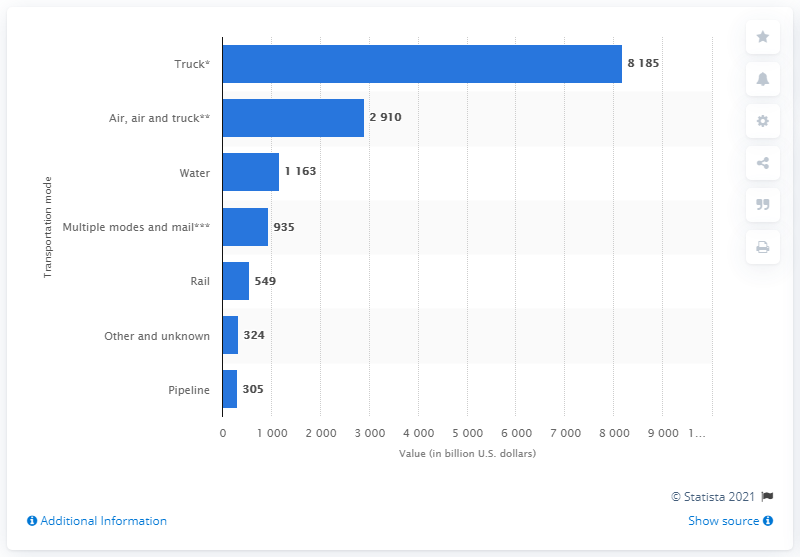List a handful of essential elements in this visual. The estimated value of U.S. imports transported by rail is approximately $549 million. 